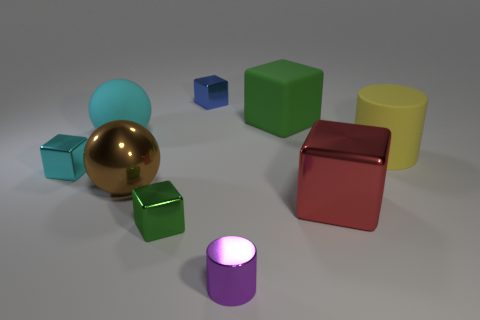Does the big rubber cube have the same color as the big shiny object that is to the left of the big green rubber cube? no 